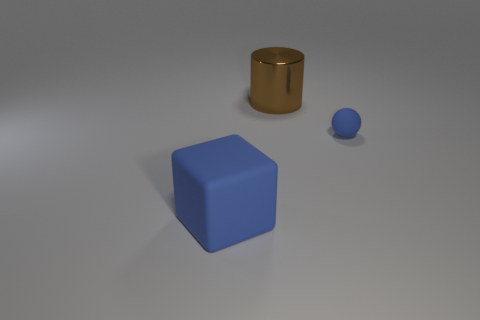Add 1 large red blocks. How many objects exist? 4 Subtract all balls. How many objects are left? 2 Subtract 0 gray blocks. How many objects are left? 3 Subtract all red shiny cylinders. Subtract all small things. How many objects are left? 2 Add 1 blue objects. How many blue objects are left? 3 Add 2 big cyan cubes. How many big cyan cubes exist? 2 